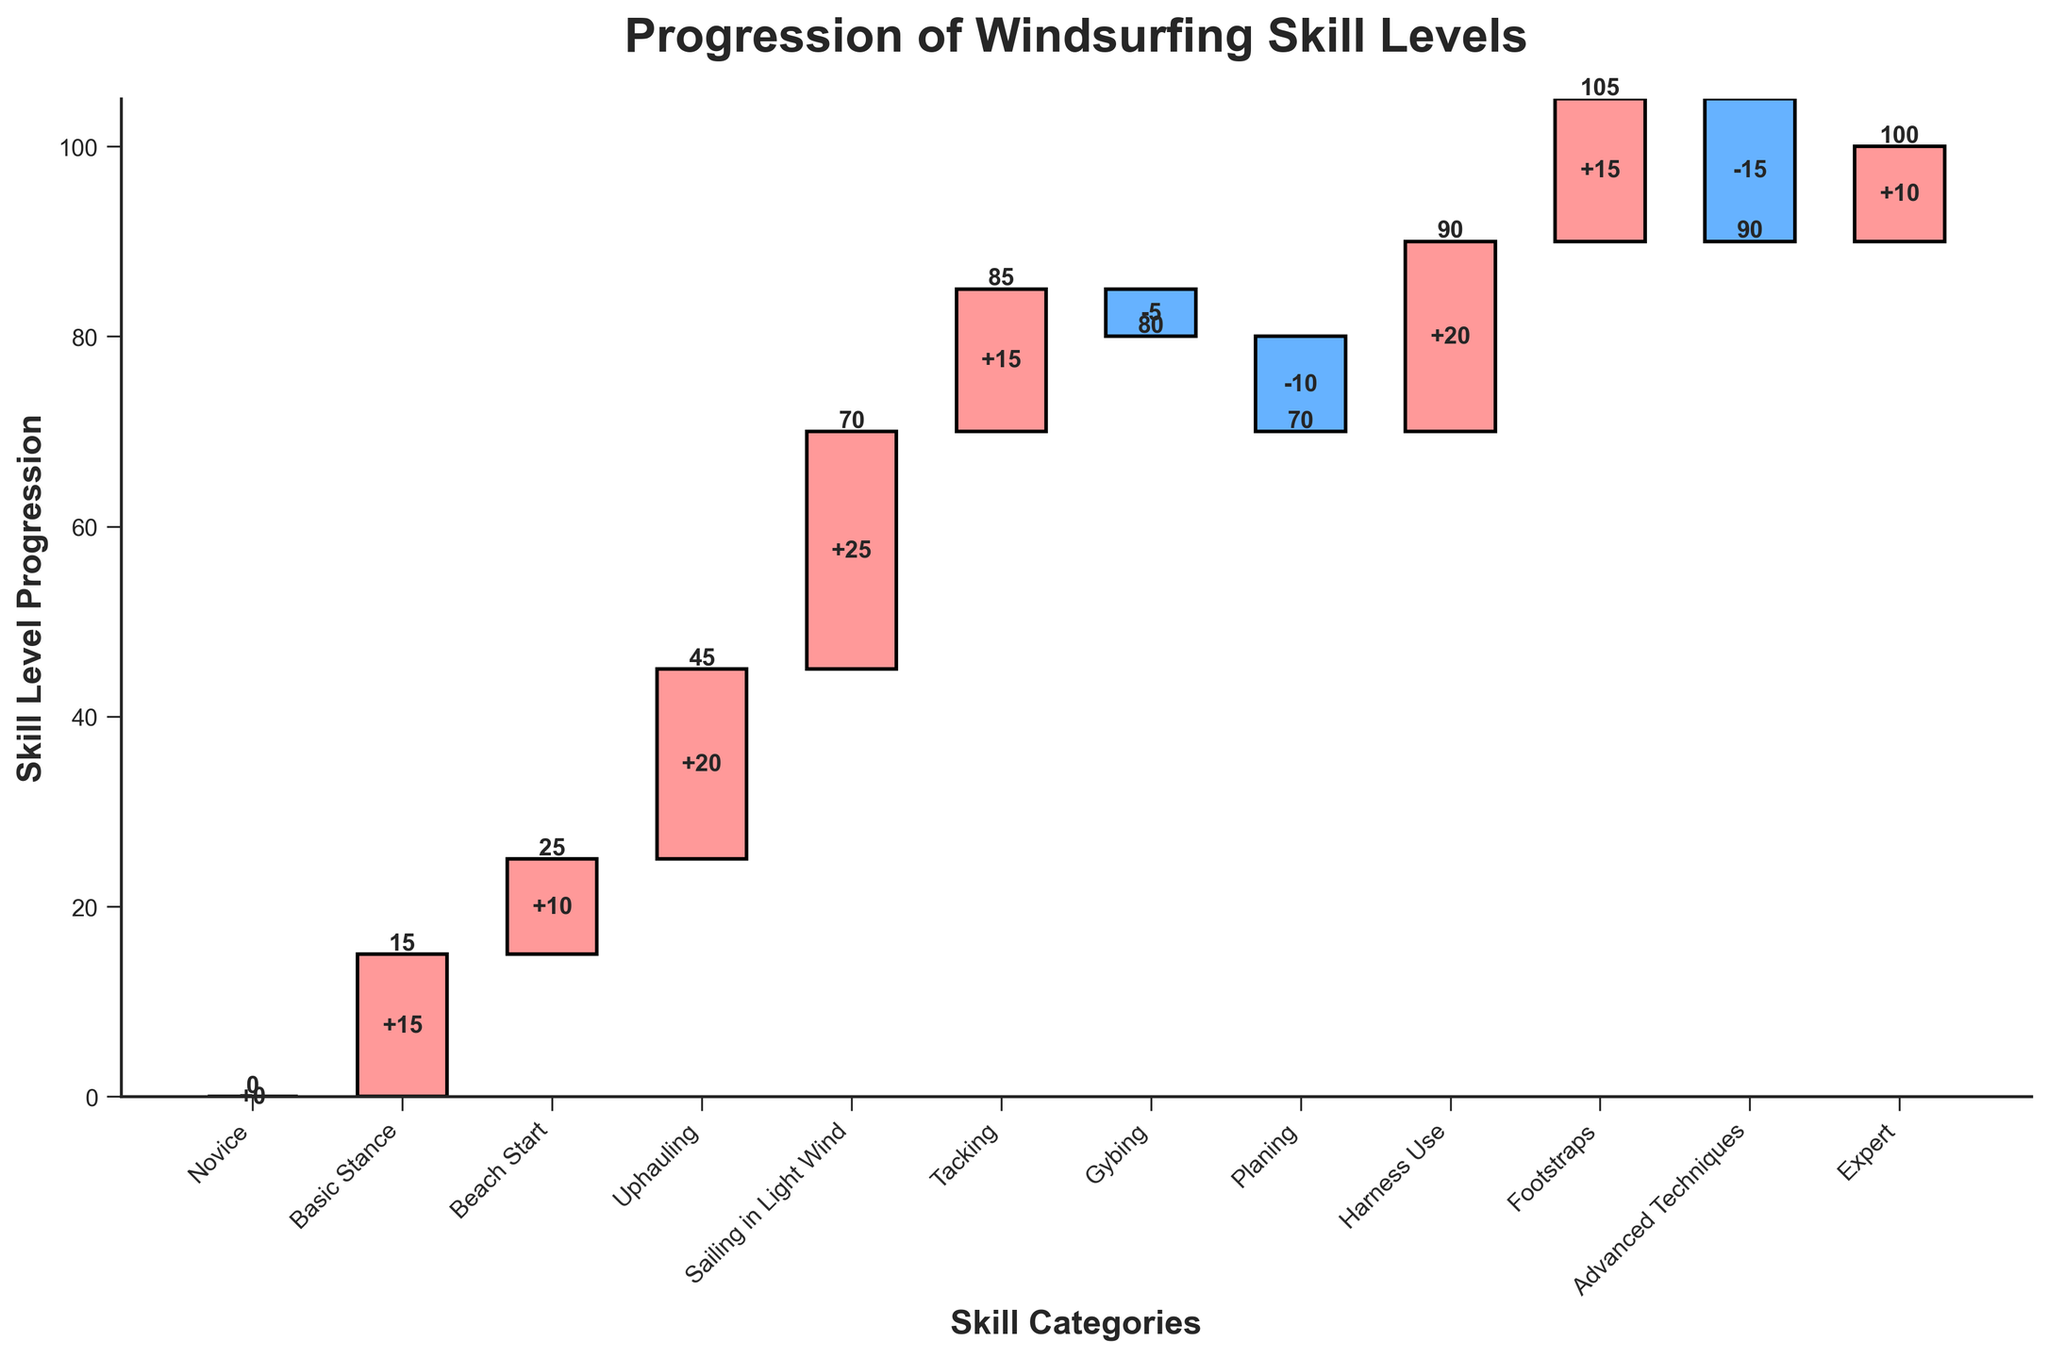What is the title of the chart? The title is displayed at the top of the chart and clearly indicates the main subject of the visualization.
Answer: Progression of Windsurfing Skill Levels What does the vertical axis represent? The vertical axis, also known as the y-axis, is labeled to indicate the measure being displayed in the chart. It represents 'Skill Level Progression'.
Answer: Skill Level Progression How many skill categories are displayed in the chart? By counting the unique skill categories listed along the horizontal axis, also known as the x-axis, we can determine the total number. There are 11 skill categories in total.
Answer: 11 Which skill category shows the highest positive contribution to skill progression? Observing the segments, we identify the one with the highest positive value, represented by the tallest bar above the baseline (not negative). 'Sailing in Light Wind' has the highest value of 25.
Answer: Sailing in Light Wind Which skill categories have a negative contribution? Negative contributions are represented by bars that extend below the baseline. Identifying these categories by their position and color helps to pinpoint them. 'Gybing', 'Planing', and 'Advanced Techniques' show negative contributions.
Answer: Gybing, Planing, Advanced Techniques What is the cumulative skill progression at the 'Expert' level? To determine this, we look for the cumulative value given at the final step of the waterfall chart, which shows the total progression after all categories have been accounted for. The cumulative skill progression at 'Expert' is 115.
Answer: 115 By how much does the 'Footstraps' skill category contribute to the overall progression? The contribution of the 'Footstraps' category is found by looking at its specific bar; it is labeled to indicate its value. 'Footstraps' contributes 15 to the overall progression.
Answer: 15 What is the cumulative skill progression just before adding 'Advanced Techniques'? This requires identifying the cumulative value at the category right before 'Advanced Techniques' and reading the displayed value. The cumulative amount before adding 'Advanced Techniques' is 140.
Answer: 140 What is the total increase in skill level represented by the positive contributions? Adding up all the positive values (+15 +10 +20 +25 +15 +20 +15 +10) gives the total increase. The total increase is 130.
Answer: 130 What is the combined effect of negative contributions in the skill progression? Summing all the negative values (-5 and -10 and -15) will provide the combined effect of the skill progression losses. The combined negative effect is -30.
Answer: -30 